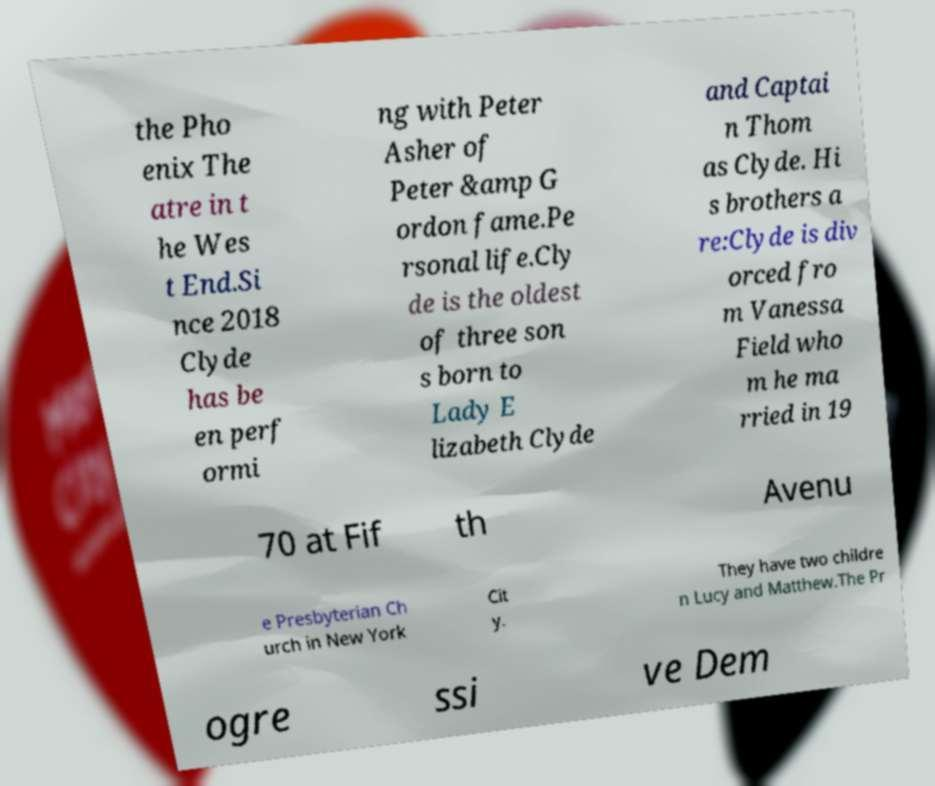I need the written content from this picture converted into text. Can you do that? the Pho enix The atre in t he Wes t End.Si nce 2018 Clyde has be en perf ormi ng with Peter Asher of Peter &amp G ordon fame.Pe rsonal life.Cly de is the oldest of three son s born to Lady E lizabeth Clyde and Captai n Thom as Clyde. Hi s brothers a re:Clyde is div orced fro m Vanessa Field who m he ma rried in 19 70 at Fif th Avenu e Presbyterian Ch urch in New York Cit y. They have two childre n Lucy and Matthew.The Pr ogre ssi ve Dem 